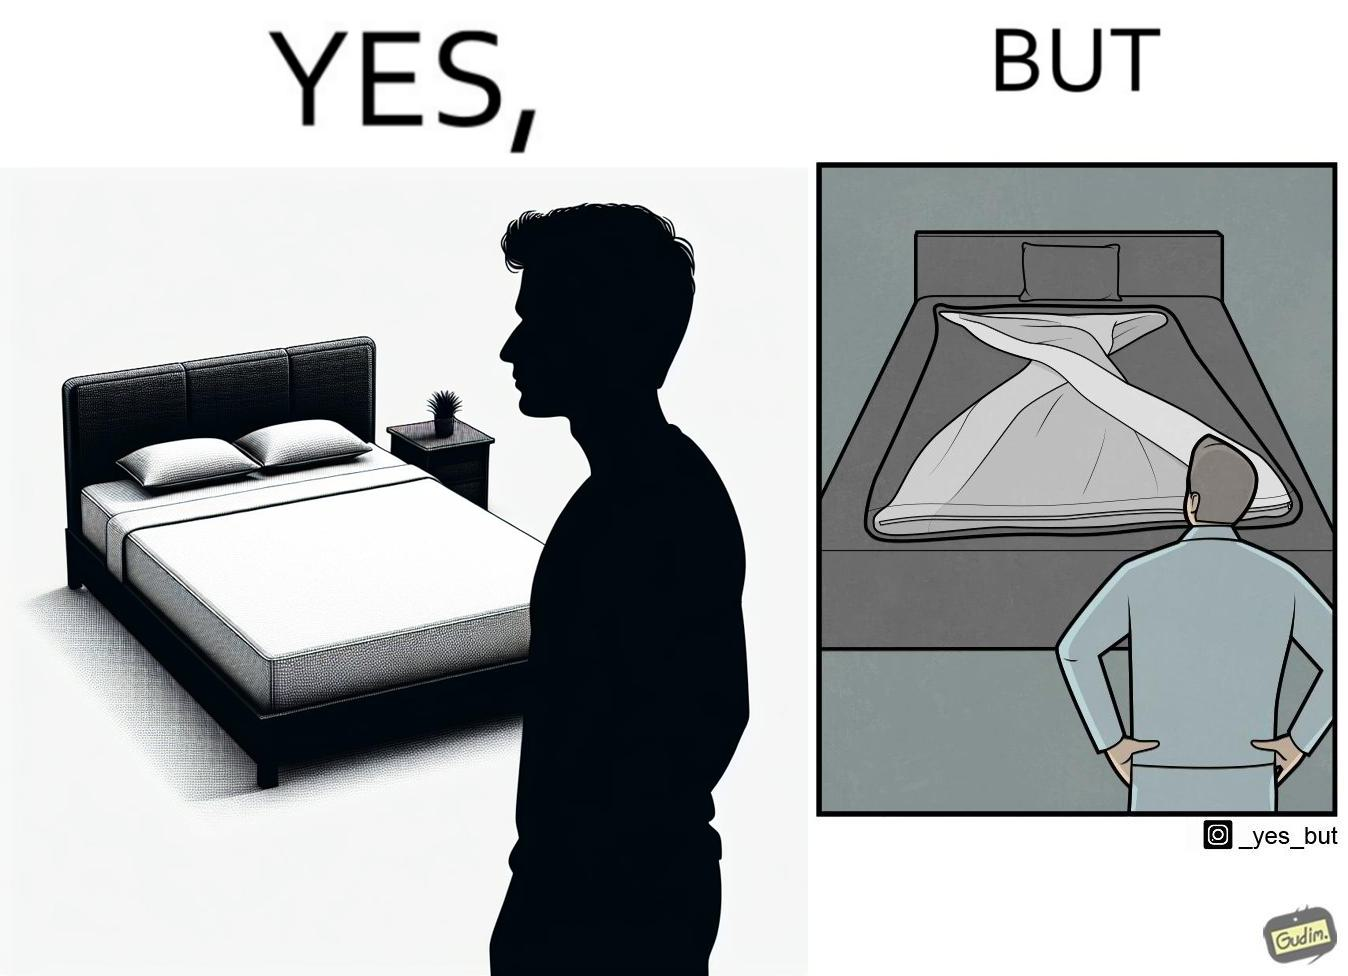Provide a description of this image. The image is funny because while the bed seems to be well made with the blanket on top, the actual blanket inside the blanket cover is twisted and not properly set. 